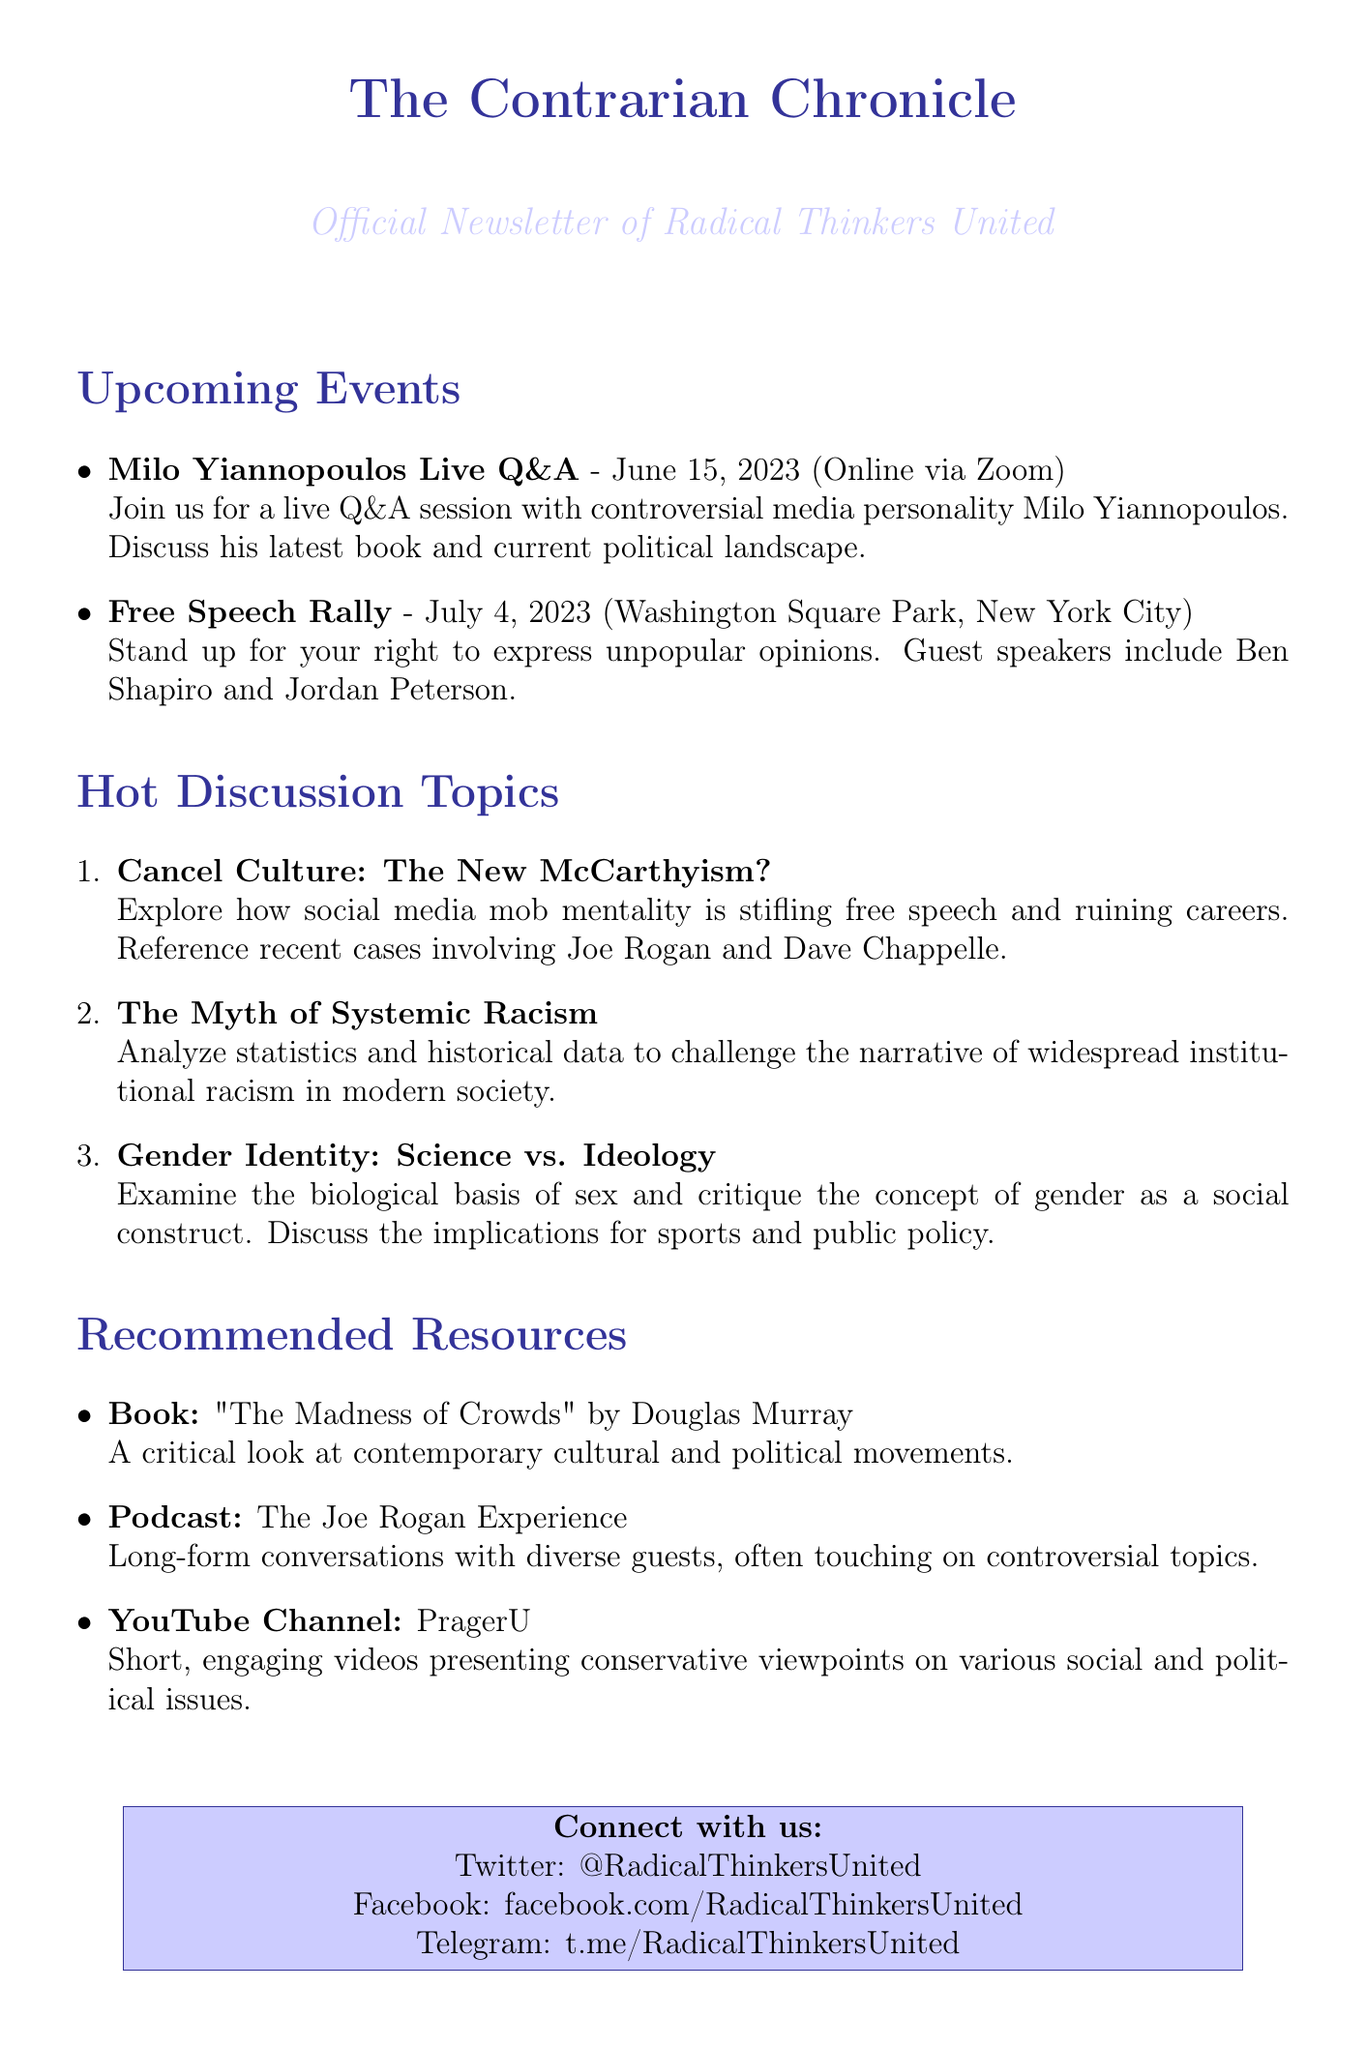What is the name of the newsletter? The name of the newsletter is explicitly stated at the beginning of the document.
Answer: The Contrarian Chronicle When is the Free Speech Rally scheduled? The document provides the date of the Free Speech Rally listed under upcoming events.
Answer: July 4, 2023 Who are the guest speakers at the Free Speech Rally? The document lists specific speakers for the Free Speech Rally in the upcoming events section.
Answer: Ben Shapiro and Jordan Peterson What topic discusses the effects of social media on free speech? This information is found under the discussion topics section and relates to cancel culture.
Answer: Cancel Culture: The New McCarthyism? What type of resource is "The Madness of Crowds"? The recommended resources section categorizes the resource as a book.
Answer: Book Which online platform can you join for daily debates? The document includes a call to action that specifies the platform for joining debates.
Answer: RadicalThinkersUnited.com What date is the live Q&A with Milo Yiannopoulos? The date is mentioned in the upcoming events section immediately following the event title.
Answer: June 15, 2023 What is the main theme of the discussion topic regarding gender identity? The document outlines the core focus of the discussion topic in its title and description.
Answer: Science vs. Ideology What type of content does the YouTube channel PragerU provide? The description of the YouTube channel specifies the nature of the content.
Answer: Conservative viewpoints 